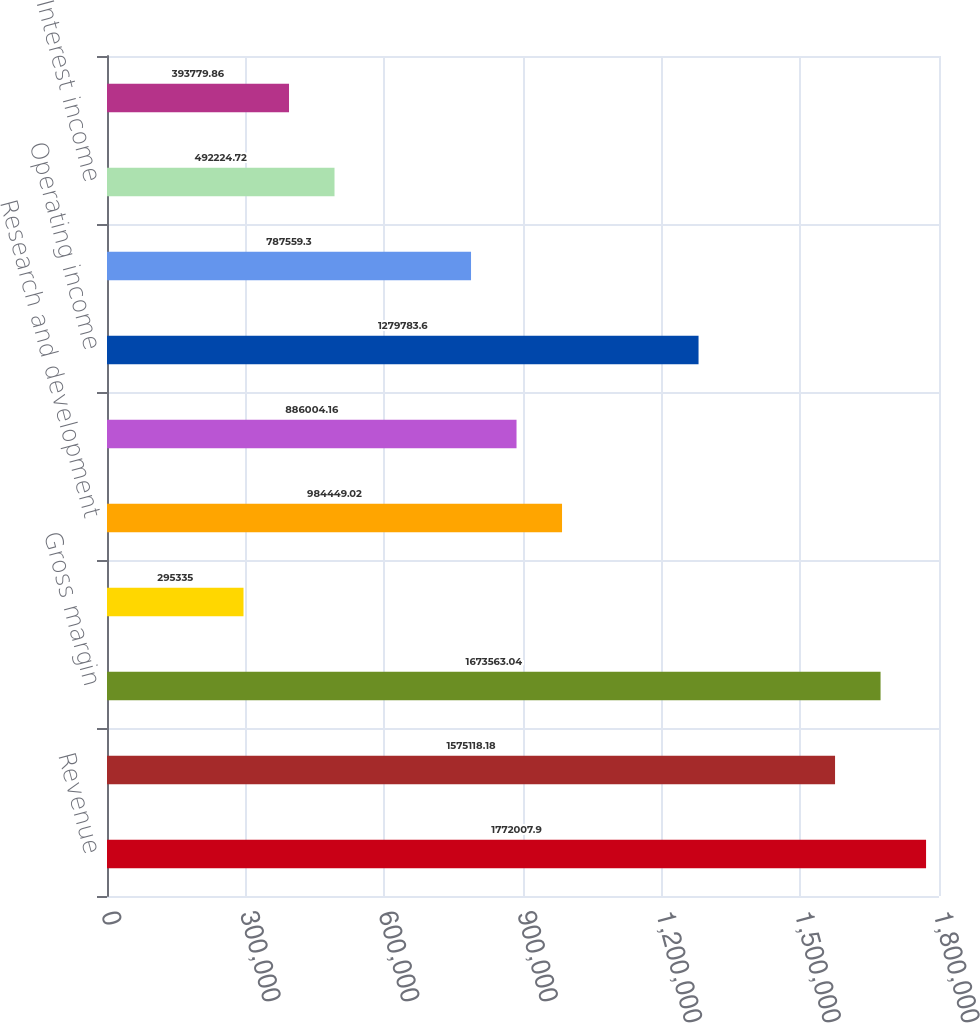Convert chart to OTSL. <chart><loc_0><loc_0><loc_500><loc_500><bar_chart><fcel>Revenue<fcel>Cost of sales<fcel>Gross margin<fcel>of Revenue<fcel>Research and development<fcel>Selling marketing general and<fcel>Operating income<fcel>Interest expense (a)<fcel>Interest income<fcel>Other net<nl><fcel>1.77201e+06<fcel>1.57512e+06<fcel>1.67356e+06<fcel>295335<fcel>984449<fcel>886004<fcel>1.27978e+06<fcel>787559<fcel>492225<fcel>393780<nl></chart> 